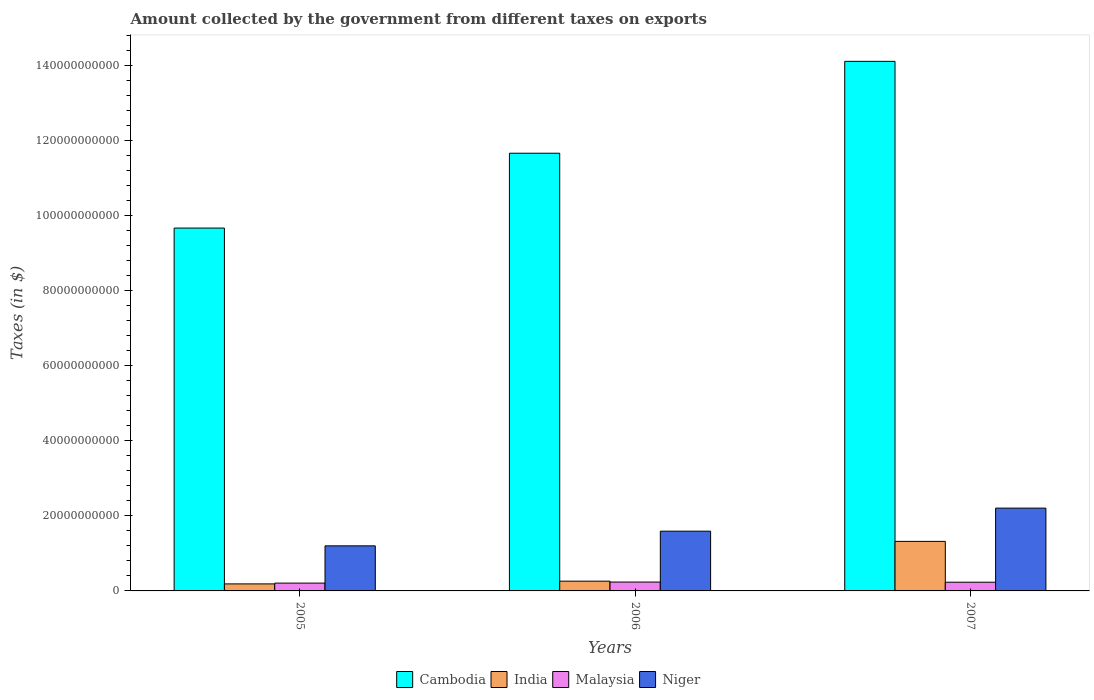How many groups of bars are there?
Keep it short and to the point. 3. Are the number of bars per tick equal to the number of legend labels?
Make the answer very short. Yes. How many bars are there on the 2nd tick from the left?
Make the answer very short. 4. How many bars are there on the 2nd tick from the right?
Keep it short and to the point. 4. In how many cases, is the number of bars for a given year not equal to the number of legend labels?
Keep it short and to the point. 0. What is the amount collected by the government from taxes on exports in Malaysia in 2007?
Provide a short and direct response. 2.32e+09. Across all years, what is the maximum amount collected by the government from taxes on exports in Malaysia?
Offer a very short reply. 2.36e+09. Across all years, what is the minimum amount collected by the government from taxes on exports in Niger?
Give a very brief answer. 1.20e+1. What is the total amount collected by the government from taxes on exports in India in the graph?
Make the answer very short. 1.77e+1. What is the difference between the amount collected by the government from taxes on exports in Niger in 2005 and that in 2006?
Keep it short and to the point. -3.91e+09. What is the difference between the amount collected by the government from taxes on exports in Malaysia in 2007 and the amount collected by the government from taxes on exports in Niger in 2005?
Make the answer very short. -9.69e+09. What is the average amount collected by the government from taxes on exports in Malaysia per year?
Make the answer very short. 2.26e+09. In the year 2006, what is the difference between the amount collected by the government from taxes on exports in Cambodia and amount collected by the government from taxes on exports in Niger?
Ensure brevity in your answer.  1.01e+11. In how many years, is the amount collected by the government from taxes on exports in Niger greater than 96000000000 $?
Your answer should be compact. 0. What is the ratio of the amount collected by the government from taxes on exports in Cambodia in 2005 to that in 2007?
Provide a short and direct response. 0.69. Is the amount collected by the government from taxes on exports in India in 2006 less than that in 2007?
Your answer should be compact. Yes. Is the difference between the amount collected by the government from taxes on exports in Cambodia in 2005 and 2006 greater than the difference between the amount collected by the government from taxes on exports in Niger in 2005 and 2006?
Make the answer very short. No. What is the difference between the highest and the second highest amount collected by the government from taxes on exports in Malaysia?
Your answer should be very brief. 3.92e+07. What is the difference between the highest and the lowest amount collected by the government from taxes on exports in India?
Ensure brevity in your answer.  1.13e+1. Is the sum of the amount collected by the government from taxes on exports in Cambodia in 2005 and 2006 greater than the maximum amount collected by the government from taxes on exports in Malaysia across all years?
Provide a short and direct response. Yes. What does the 3rd bar from the left in 2005 represents?
Offer a very short reply. Malaysia. What does the 4th bar from the right in 2005 represents?
Offer a very short reply. Cambodia. How many bars are there?
Give a very brief answer. 12. Are all the bars in the graph horizontal?
Keep it short and to the point. No. How many years are there in the graph?
Offer a very short reply. 3. What is the difference between two consecutive major ticks on the Y-axis?
Give a very brief answer. 2.00e+1. Are the values on the major ticks of Y-axis written in scientific E-notation?
Offer a very short reply. No. Does the graph contain any zero values?
Offer a very short reply. No. Where does the legend appear in the graph?
Offer a very short reply. Bottom center. How many legend labels are there?
Your answer should be compact. 4. How are the legend labels stacked?
Give a very brief answer. Horizontal. What is the title of the graph?
Your response must be concise. Amount collected by the government from different taxes on exports. Does "Chile" appear as one of the legend labels in the graph?
Give a very brief answer. No. What is the label or title of the X-axis?
Provide a short and direct response. Years. What is the label or title of the Y-axis?
Your response must be concise. Taxes (in $). What is the Taxes (in $) in Cambodia in 2005?
Make the answer very short. 9.67e+1. What is the Taxes (in $) in India in 2005?
Offer a very short reply. 1.87e+09. What is the Taxes (in $) of Malaysia in 2005?
Your response must be concise. 2.08e+09. What is the Taxes (in $) of Niger in 2005?
Offer a very short reply. 1.20e+1. What is the Taxes (in $) in Cambodia in 2006?
Your answer should be very brief. 1.17e+11. What is the Taxes (in $) of India in 2006?
Your answer should be very brief. 2.60e+09. What is the Taxes (in $) of Malaysia in 2006?
Your answer should be very brief. 2.36e+09. What is the Taxes (in $) of Niger in 2006?
Make the answer very short. 1.59e+1. What is the Taxes (in $) in Cambodia in 2007?
Keep it short and to the point. 1.41e+11. What is the Taxes (in $) in India in 2007?
Provide a succinct answer. 1.32e+1. What is the Taxes (in $) of Malaysia in 2007?
Keep it short and to the point. 2.32e+09. What is the Taxes (in $) of Niger in 2007?
Offer a terse response. 2.21e+1. Across all years, what is the maximum Taxes (in $) of Cambodia?
Give a very brief answer. 1.41e+11. Across all years, what is the maximum Taxes (in $) of India?
Offer a terse response. 1.32e+1. Across all years, what is the maximum Taxes (in $) of Malaysia?
Make the answer very short. 2.36e+09. Across all years, what is the maximum Taxes (in $) of Niger?
Your response must be concise. 2.21e+1. Across all years, what is the minimum Taxes (in $) in Cambodia?
Your answer should be very brief. 9.67e+1. Across all years, what is the minimum Taxes (in $) of India?
Make the answer very short. 1.87e+09. Across all years, what is the minimum Taxes (in $) of Malaysia?
Provide a succinct answer. 2.08e+09. Across all years, what is the minimum Taxes (in $) in Niger?
Ensure brevity in your answer.  1.20e+1. What is the total Taxes (in $) of Cambodia in the graph?
Give a very brief answer. 3.54e+11. What is the total Taxes (in $) in India in the graph?
Your answer should be compact. 1.77e+1. What is the total Taxes (in $) in Malaysia in the graph?
Keep it short and to the point. 6.77e+09. What is the total Taxes (in $) in Niger in the graph?
Your response must be concise. 5.00e+1. What is the difference between the Taxes (in $) of Cambodia in 2005 and that in 2006?
Make the answer very short. -1.99e+1. What is the difference between the Taxes (in $) of India in 2005 and that in 2006?
Offer a very short reply. -7.30e+08. What is the difference between the Taxes (in $) of Malaysia in 2005 and that in 2006?
Provide a short and direct response. -2.77e+08. What is the difference between the Taxes (in $) in Niger in 2005 and that in 2006?
Offer a terse response. -3.91e+09. What is the difference between the Taxes (in $) in Cambodia in 2005 and that in 2007?
Your answer should be compact. -4.44e+1. What is the difference between the Taxes (in $) in India in 2005 and that in 2007?
Keep it short and to the point. -1.13e+1. What is the difference between the Taxes (in $) in Malaysia in 2005 and that in 2007?
Keep it short and to the point. -2.37e+08. What is the difference between the Taxes (in $) of Niger in 2005 and that in 2007?
Offer a very short reply. -1.01e+1. What is the difference between the Taxes (in $) of Cambodia in 2006 and that in 2007?
Give a very brief answer. -2.45e+1. What is the difference between the Taxes (in $) in India in 2006 and that in 2007?
Offer a terse response. -1.06e+1. What is the difference between the Taxes (in $) of Malaysia in 2006 and that in 2007?
Give a very brief answer. 3.92e+07. What is the difference between the Taxes (in $) in Niger in 2006 and that in 2007?
Provide a succinct answer. -6.14e+09. What is the difference between the Taxes (in $) of Cambodia in 2005 and the Taxes (in $) of India in 2006?
Offer a terse response. 9.41e+1. What is the difference between the Taxes (in $) in Cambodia in 2005 and the Taxes (in $) in Malaysia in 2006?
Provide a short and direct response. 9.43e+1. What is the difference between the Taxes (in $) of Cambodia in 2005 and the Taxes (in $) of Niger in 2006?
Give a very brief answer. 8.08e+1. What is the difference between the Taxes (in $) of India in 2005 and the Taxes (in $) of Malaysia in 2006?
Provide a succinct answer. -4.92e+08. What is the difference between the Taxes (in $) of India in 2005 and the Taxes (in $) of Niger in 2006?
Provide a succinct answer. -1.41e+1. What is the difference between the Taxes (in $) of Malaysia in 2005 and the Taxes (in $) of Niger in 2006?
Your response must be concise. -1.38e+1. What is the difference between the Taxes (in $) of Cambodia in 2005 and the Taxes (in $) of India in 2007?
Offer a very short reply. 8.35e+1. What is the difference between the Taxes (in $) of Cambodia in 2005 and the Taxes (in $) of Malaysia in 2007?
Ensure brevity in your answer.  9.44e+1. What is the difference between the Taxes (in $) in Cambodia in 2005 and the Taxes (in $) in Niger in 2007?
Make the answer very short. 7.46e+1. What is the difference between the Taxes (in $) in India in 2005 and the Taxes (in $) in Malaysia in 2007?
Ensure brevity in your answer.  -4.52e+08. What is the difference between the Taxes (in $) in India in 2005 and the Taxes (in $) in Niger in 2007?
Make the answer very short. -2.02e+1. What is the difference between the Taxes (in $) of Malaysia in 2005 and the Taxes (in $) of Niger in 2007?
Ensure brevity in your answer.  -2.00e+1. What is the difference between the Taxes (in $) in Cambodia in 2006 and the Taxes (in $) in India in 2007?
Give a very brief answer. 1.03e+11. What is the difference between the Taxes (in $) of Cambodia in 2006 and the Taxes (in $) of Malaysia in 2007?
Keep it short and to the point. 1.14e+11. What is the difference between the Taxes (in $) of Cambodia in 2006 and the Taxes (in $) of Niger in 2007?
Offer a terse response. 9.46e+1. What is the difference between the Taxes (in $) in India in 2006 and the Taxes (in $) in Malaysia in 2007?
Make the answer very short. 2.78e+08. What is the difference between the Taxes (in $) in India in 2006 and the Taxes (in $) in Niger in 2007?
Offer a very short reply. -1.95e+1. What is the difference between the Taxes (in $) of Malaysia in 2006 and the Taxes (in $) of Niger in 2007?
Keep it short and to the point. -1.97e+1. What is the average Taxes (in $) of Cambodia per year?
Keep it short and to the point. 1.18e+11. What is the average Taxes (in $) of India per year?
Your answer should be compact. 5.89e+09. What is the average Taxes (in $) of Malaysia per year?
Provide a short and direct response. 2.26e+09. What is the average Taxes (in $) of Niger per year?
Your answer should be very brief. 1.67e+1. In the year 2005, what is the difference between the Taxes (in $) of Cambodia and Taxes (in $) of India?
Your answer should be very brief. 9.48e+1. In the year 2005, what is the difference between the Taxes (in $) of Cambodia and Taxes (in $) of Malaysia?
Your answer should be compact. 9.46e+1. In the year 2005, what is the difference between the Taxes (in $) of Cambodia and Taxes (in $) of Niger?
Your answer should be very brief. 8.47e+1. In the year 2005, what is the difference between the Taxes (in $) in India and Taxes (in $) in Malaysia?
Your response must be concise. -2.15e+08. In the year 2005, what is the difference between the Taxes (in $) in India and Taxes (in $) in Niger?
Your answer should be compact. -1.01e+1. In the year 2005, what is the difference between the Taxes (in $) of Malaysia and Taxes (in $) of Niger?
Provide a succinct answer. -9.93e+09. In the year 2006, what is the difference between the Taxes (in $) in Cambodia and Taxes (in $) in India?
Give a very brief answer. 1.14e+11. In the year 2006, what is the difference between the Taxes (in $) in Cambodia and Taxes (in $) in Malaysia?
Offer a terse response. 1.14e+11. In the year 2006, what is the difference between the Taxes (in $) of Cambodia and Taxes (in $) of Niger?
Your answer should be very brief. 1.01e+11. In the year 2006, what is the difference between the Taxes (in $) of India and Taxes (in $) of Malaysia?
Keep it short and to the point. 2.38e+08. In the year 2006, what is the difference between the Taxes (in $) in India and Taxes (in $) in Niger?
Your answer should be very brief. -1.33e+1. In the year 2006, what is the difference between the Taxes (in $) in Malaysia and Taxes (in $) in Niger?
Make the answer very short. -1.36e+1. In the year 2007, what is the difference between the Taxes (in $) of Cambodia and Taxes (in $) of India?
Offer a terse response. 1.28e+11. In the year 2007, what is the difference between the Taxes (in $) in Cambodia and Taxes (in $) in Malaysia?
Provide a short and direct response. 1.39e+11. In the year 2007, what is the difference between the Taxes (in $) of Cambodia and Taxes (in $) of Niger?
Offer a very short reply. 1.19e+11. In the year 2007, what is the difference between the Taxes (in $) of India and Taxes (in $) of Malaysia?
Give a very brief answer. 1.09e+1. In the year 2007, what is the difference between the Taxes (in $) of India and Taxes (in $) of Niger?
Your response must be concise. -8.86e+09. In the year 2007, what is the difference between the Taxes (in $) of Malaysia and Taxes (in $) of Niger?
Offer a very short reply. -1.97e+1. What is the ratio of the Taxes (in $) of Cambodia in 2005 to that in 2006?
Your answer should be very brief. 0.83. What is the ratio of the Taxes (in $) in India in 2005 to that in 2006?
Offer a very short reply. 0.72. What is the ratio of the Taxes (in $) of Malaysia in 2005 to that in 2006?
Make the answer very short. 0.88. What is the ratio of the Taxes (in $) of Niger in 2005 to that in 2006?
Make the answer very short. 0.75. What is the ratio of the Taxes (in $) in Cambodia in 2005 to that in 2007?
Provide a succinct answer. 0.69. What is the ratio of the Taxes (in $) in India in 2005 to that in 2007?
Provide a short and direct response. 0.14. What is the ratio of the Taxes (in $) in Malaysia in 2005 to that in 2007?
Make the answer very short. 0.9. What is the ratio of the Taxes (in $) in Niger in 2005 to that in 2007?
Your answer should be compact. 0.54. What is the ratio of the Taxes (in $) in Cambodia in 2006 to that in 2007?
Provide a succinct answer. 0.83. What is the ratio of the Taxes (in $) in India in 2006 to that in 2007?
Your response must be concise. 0.2. What is the ratio of the Taxes (in $) of Malaysia in 2006 to that in 2007?
Ensure brevity in your answer.  1.02. What is the ratio of the Taxes (in $) in Niger in 2006 to that in 2007?
Offer a terse response. 0.72. What is the difference between the highest and the second highest Taxes (in $) of Cambodia?
Your response must be concise. 2.45e+1. What is the difference between the highest and the second highest Taxes (in $) in India?
Keep it short and to the point. 1.06e+1. What is the difference between the highest and the second highest Taxes (in $) of Malaysia?
Offer a terse response. 3.92e+07. What is the difference between the highest and the second highest Taxes (in $) in Niger?
Give a very brief answer. 6.14e+09. What is the difference between the highest and the lowest Taxes (in $) in Cambodia?
Ensure brevity in your answer.  4.44e+1. What is the difference between the highest and the lowest Taxes (in $) of India?
Offer a terse response. 1.13e+1. What is the difference between the highest and the lowest Taxes (in $) in Malaysia?
Ensure brevity in your answer.  2.77e+08. What is the difference between the highest and the lowest Taxes (in $) in Niger?
Ensure brevity in your answer.  1.01e+1. 